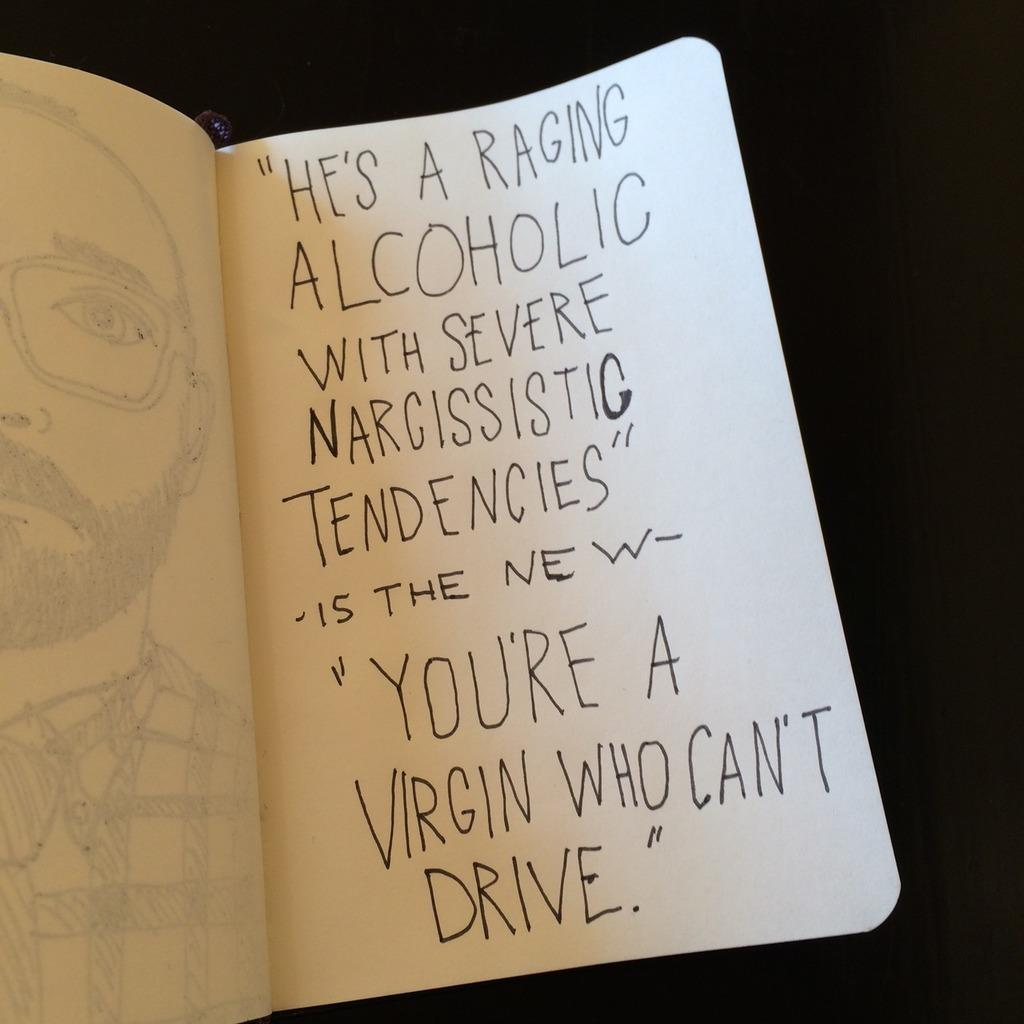<image>
Create a compact narrative representing the image presented. A book is open showing a sketch on one side and text on the other that mentions a raging alcoholic and narcissistic tendencies. 